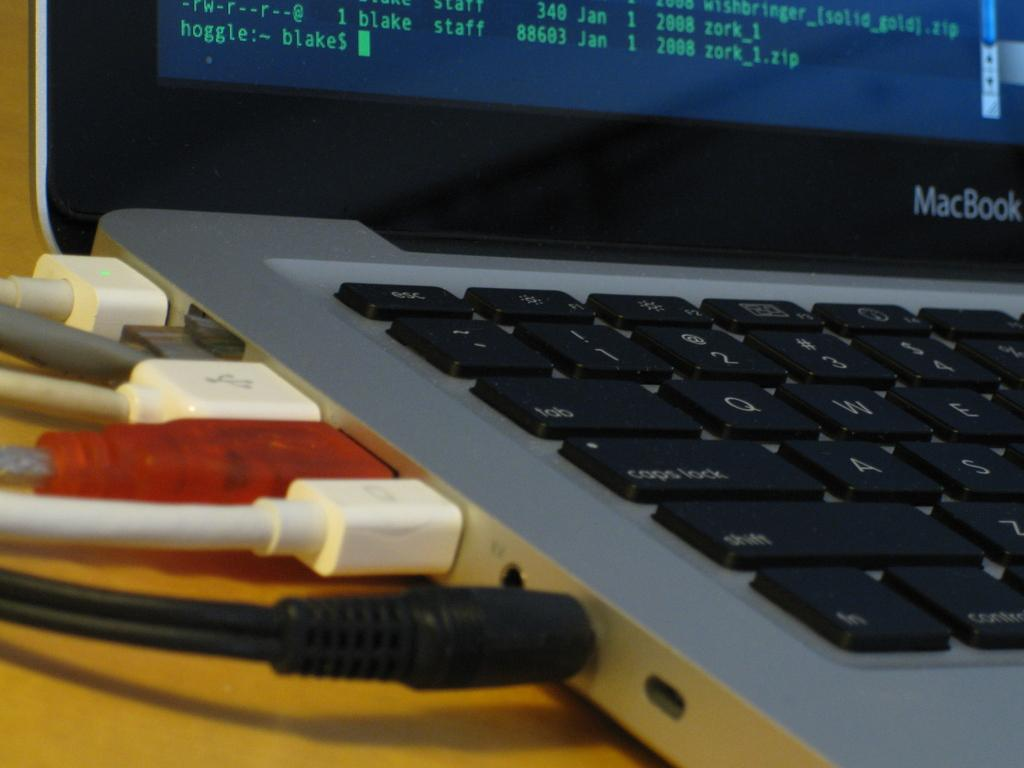<image>
Offer a succinct explanation of the picture presented. A Macbook shows all the cords attached to it 